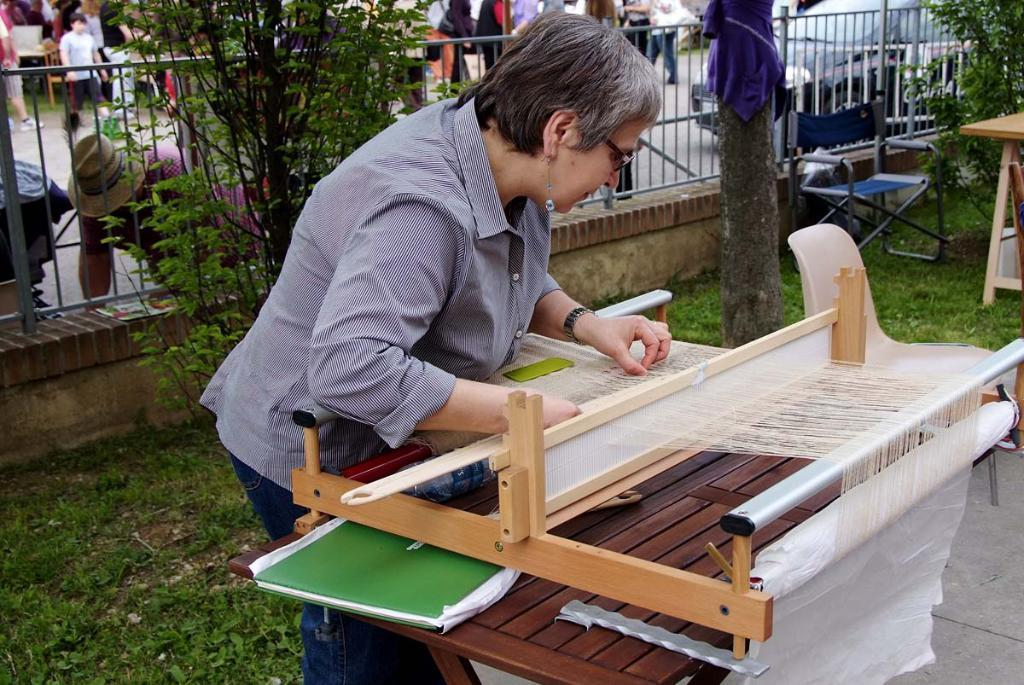What is the woman in the image doing? The woman is weaving wool. What can be seen in the background of the image? There are trees visible in the image. What piece of furniture is present in the image? There is a chair in the image. What else is happening in the image? There are people standing on the road in the image. Where is the map located in the image? There is no map present in the image. Can you see any icicles hanging from the trees in the image? There are no icicles visible in the image; it appears to be a warm setting with trees. 